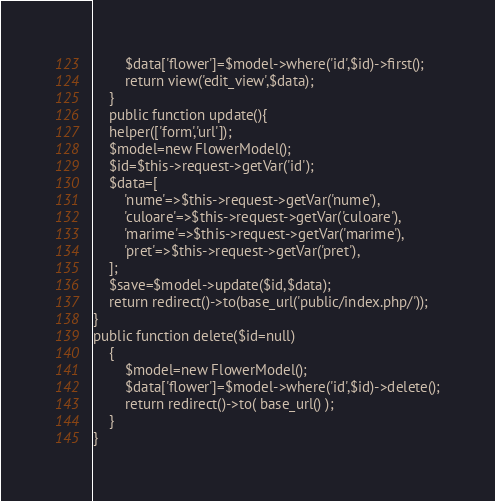Convert code to text. <code><loc_0><loc_0><loc_500><loc_500><_PHP_>        $data['flower']=$model->where('id',$id)->first();
        return view('edit_view',$data);
    }
    public function update(){
    helper(['form','url']);
    $model=new FlowerModel();
    $id=$this->request->getVar('id');
    $data=[
        'nume'=>$this->request->getVar('nume'),
        'culoare'=>$this->request->getVar('culoare'),
        'marime'=>$this->request->getVar('marime'),
        'pret'=>$this->request->getVar('pret'),
    ];
    $save=$model->update($id,$data);
    return redirect()->to(base_url('public/index.php/'));
}
public function delete($id=null)
    {
        $model=new FlowerModel();
        $data['flower']=$model->where('id',$id)->delete();
        return redirect()->to( base_url() );
    }
}
</code> 